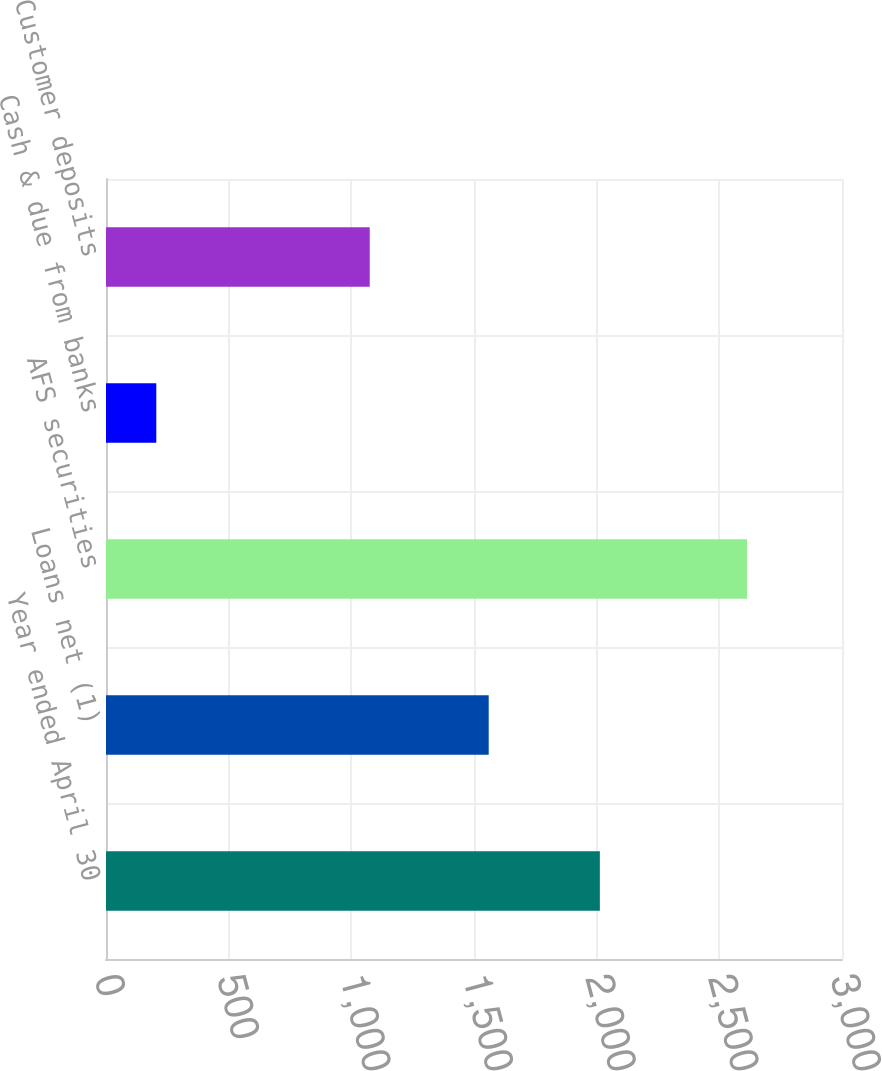Convert chart. <chart><loc_0><loc_0><loc_500><loc_500><bar_chart><fcel>Year ended April 30<fcel>Loans net (1)<fcel>AFS securities<fcel>Cash & due from banks<fcel>Customer deposits<nl><fcel>2013<fcel>1560<fcel>2613<fcel>205<fcel>1075<nl></chart> 